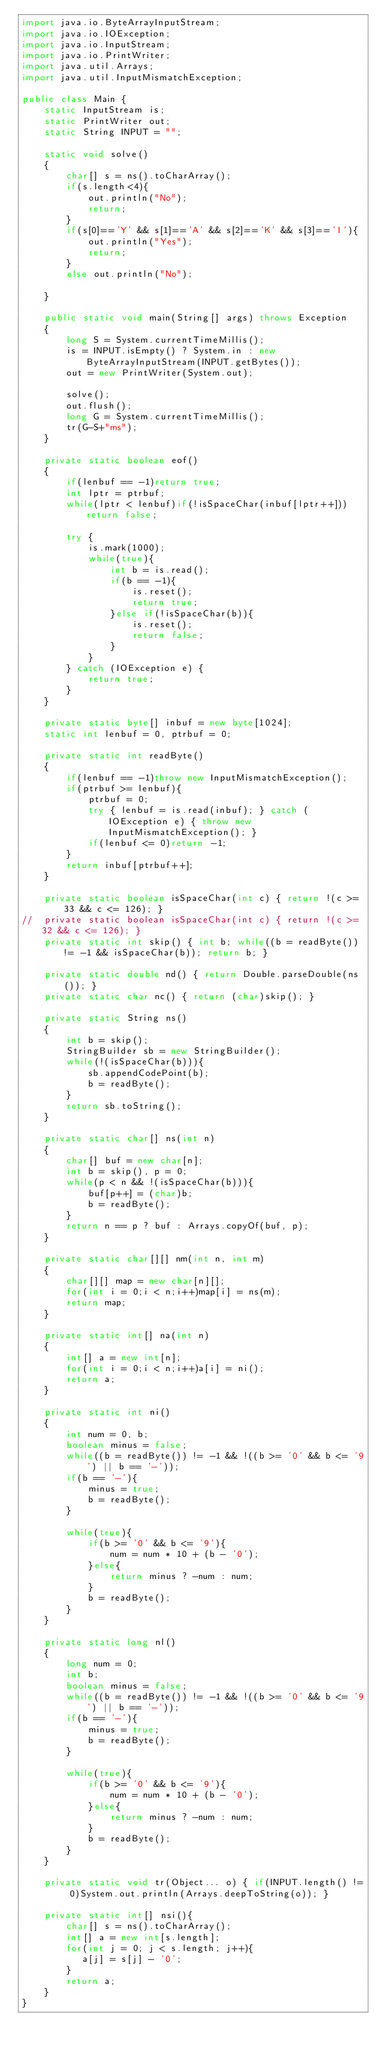Convert code to text. <code><loc_0><loc_0><loc_500><loc_500><_Java_>import java.io.ByteArrayInputStream;
import java.io.IOException;
import java.io.InputStream;
import java.io.PrintWriter;
import java.util.Arrays;
import java.util.InputMismatchException;

public class Main {
    static InputStream is;
    static PrintWriter out;
    static String INPUT = "";
    
    static void solve()
    {
        char[] s = ns().toCharArray();
        if(s.length<4){
            out.println("No");
            return;
        }
        if(s[0]=='Y' && s[1]=='A' && s[2]=='K' && s[3]=='I'){
            out.println("Yes");
            return;
        }
        else out.println("No");
        
    }
    
    public static void main(String[] args) throws Exception
    {
        long S = System.currentTimeMillis();
        is = INPUT.isEmpty() ? System.in : new ByteArrayInputStream(INPUT.getBytes());
        out = new PrintWriter(System.out);
        
        solve();
        out.flush();
        long G = System.currentTimeMillis();
        tr(G-S+"ms");
    }
    
    private static boolean eof()
    {
        if(lenbuf == -1)return true;
        int lptr = ptrbuf;
        while(lptr < lenbuf)if(!isSpaceChar(inbuf[lptr++]))return false;
        
        try {
            is.mark(1000);
            while(true){
                int b = is.read();
                if(b == -1){
                    is.reset();
                    return true;
                }else if(!isSpaceChar(b)){
                    is.reset();
                    return false;
                }
            }
        } catch (IOException e) {
            return true;
        }
    }
    
    private static byte[] inbuf = new byte[1024];
    static int lenbuf = 0, ptrbuf = 0;
    
    private static int readByte()
    {
        if(lenbuf == -1)throw new InputMismatchException();
        if(ptrbuf >= lenbuf){
            ptrbuf = 0;
            try { lenbuf = is.read(inbuf); } catch (IOException e) { throw new InputMismatchException(); }
            if(lenbuf <= 0)return -1;
        }
        return inbuf[ptrbuf++];
    }
    
    private static boolean isSpaceChar(int c) { return !(c >= 33 && c <= 126); }
//  private static boolean isSpaceChar(int c) { return !(c >= 32 && c <= 126); }
    private static int skip() { int b; while((b = readByte()) != -1 && isSpaceChar(b)); return b; }
    
    private static double nd() { return Double.parseDouble(ns()); }
    private static char nc() { return (char)skip(); }
    
    private static String ns()
    {
        int b = skip();
        StringBuilder sb = new StringBuilder();
        while(!(isSpaceChar(b))){
            sb.appendCodePoint(b);
            b = readByte();
        }
        return sb.toString();
    }
    
    private static char[] ns(int n)
    {
        char[] buf = new char[n];
        int b = skip(), p = 0;
        while(p < n && !(isSpaceChar(b))){
            buf[p++] = (char)b;
            b = readByte();
        }
        return n == p ? buf : Arrays.copyOf(buf, p);
    }
    
    private static char[][] nm(int n, int m)
    {
        char[][] map = new char[n][];
        for(int i = 0;i < n;i++)map[i] = ns(m);
        return map;
    }
    
    private static int[] na(int n)
    {
        int[] a = new int[n];
        for(int i = 0;i < n;i++)a[i] = ni();
        return a;
    }
    
    private static int ni()
    {
        int num = 0, b;
        boolean minus = false;
        while((b = readByte()) != -1 && !((b >= '0' && b <= '9') || b == '-'));
        if(b == '-'){
            minus = true;
            b = readByte();
        }
        
        while(true){
            if(b >= '0' && b <= '9'){
                num = num * 10 + (b - '0');
            }else{
                return minus ? -num : num;
            }
            b = readByte();
        }
    }
    
    private static long nl()
    {
        long num = 0;
        int b;
        boolean minus = false;
        while((b = readByte()) != -1 && !((b >= '0' && b <= '9') || b == '-'));
        if(b == '-'){
            minus = true;
            b = readByte();
        }
        
        while(true){
            if(b >= '0' && b <= '9'){
                num = num * 10 + (b - '0');
            }else{
                return minus ? -num : num;
            }
            b = readByte();
        }
    }
    
    private static void tr(Object... o) { if(INPUT.length() != 0)System.out.println(Arrays.deepToString(o)); }

    private static int[] nsi(){
        char[] s = ns().toCharArray();
        int[] a = new int[s.length];
        for(int j = 0; j < s.length; j++){
           a[j] = s[j] - '0';
        }
        return a;
    }
}</code> 